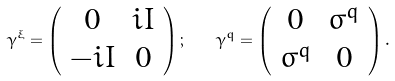<formula> <loc_0><loc_0><loc_500><loc_500>\gamma ^ { \xi } = \left ( \begin{array} { c c } 0 & i I \\ - i I & 0 \end{array} \right ) ; \quad \gamma ^ { q } = \left ( \begin{array} { c c } 0 & \sigma ^ { q } \\ \sigma ^ { q } & 0 \end{array} \right ) .</formula> 